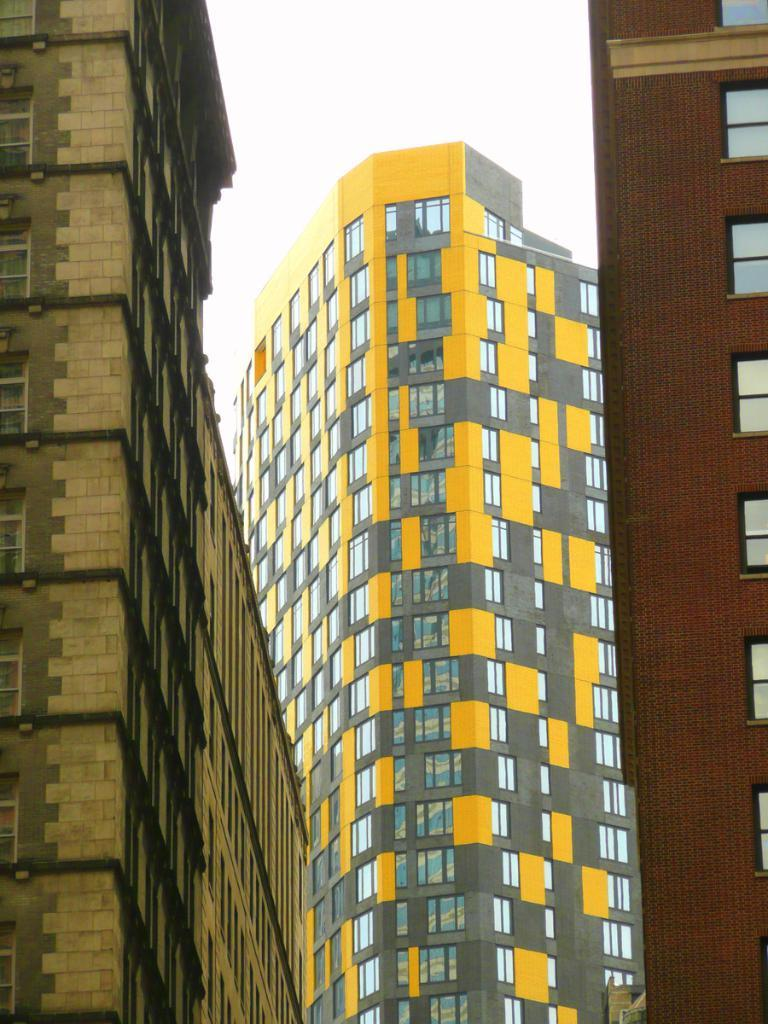What type of structures are depicted in the image? There are tall buildings in the picture. What feature is common among the buildings? The buildings have plenty of windows. How many buildings are visible in the image? There are three buildings in the picture. What can be seen in the background of the image? The sky is visible in the background of the image. Where is the shelf located in the image? There is no shelf present in the image. What color is the scarf draped over the beam in the image? There is no scarf or beam present in the image. 